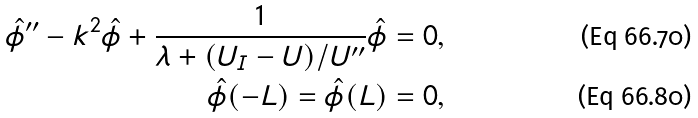<formula> <loc_0><loc_0><loc_500><loc_500>\hat { \phi } ^ { \prime \prime } - k ^ { 2 } \hat { \phi } + \frac { 1 } { \lambda + ( U _ { I } - U ) / U ^ { \prime \prime } } \hat { \phi } = 0 , \\ \hat { \phi } ( - L ) = \hat { \phi } ( L ) = 0 ,</formula> 